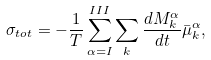<formula> <loc_0><loc_0><loc_500><loc_500>\sigma _ { t o t } = - \frac { 1 } { T } \sum _ { \alpha = I } ^ { I I I } \sum _ { k } \frac { d M ^ { \alpha } _ { k } } { d t } \bar { \mu } _ { k } ^ { \alpha } ,</formula> 